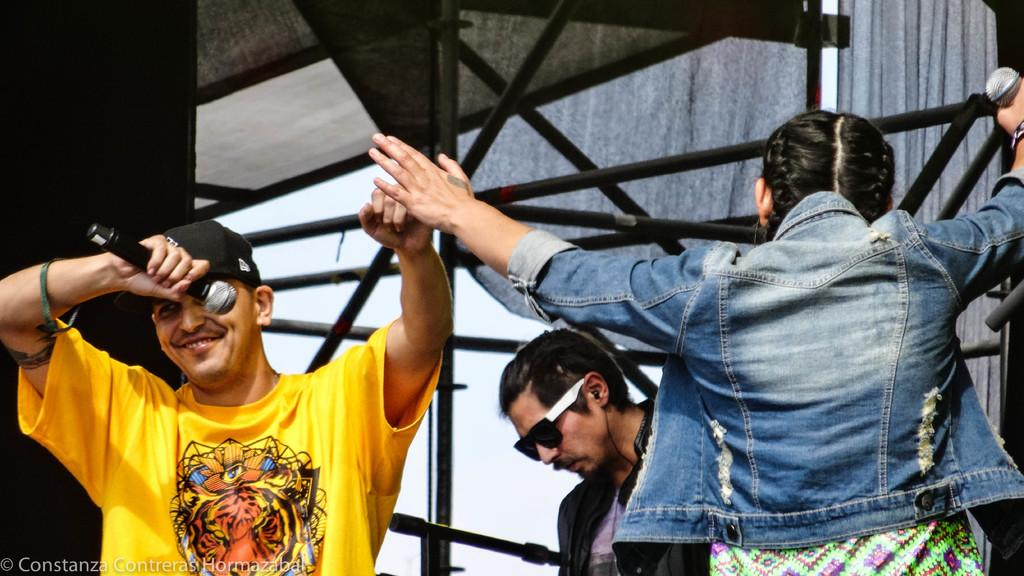How many people are in the image? There are people in the image, but the exact number is not specified. What are two people doing in the image? Two people are holding microphones in the image. What can be seen in the background of the image? There are rods, a wall, and curtains in the background of the image. Is there any text or logo visible in the image? Yes, there is a watermark in the bottom left side of the image. How many letters are visible on the dime in the image? There is no dime present in the image, so it is not possible to determine how many letters might be visible on it. 